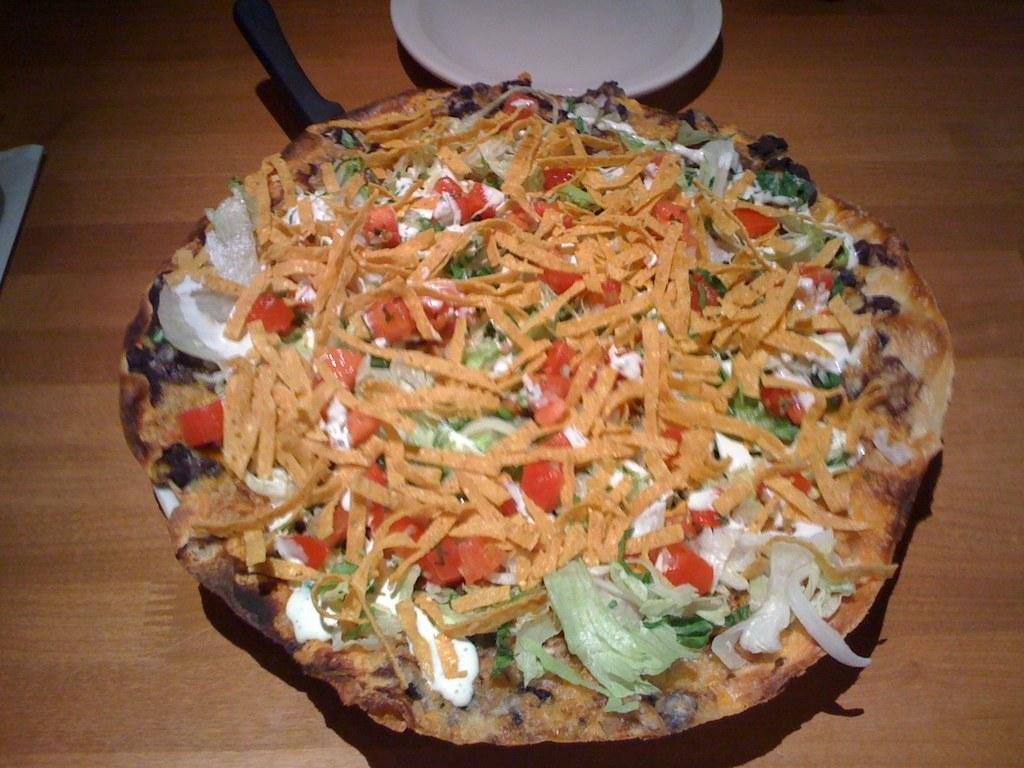What is present on the plate in the image? There is food on the plate in the image. What type of surface is visible at the bottom of the image? There is a wooden surface at the bottom of the image. What advice does the plate give to the food in the image? The plate does not give any advice to the food in the image, as it is an inanimate object. 